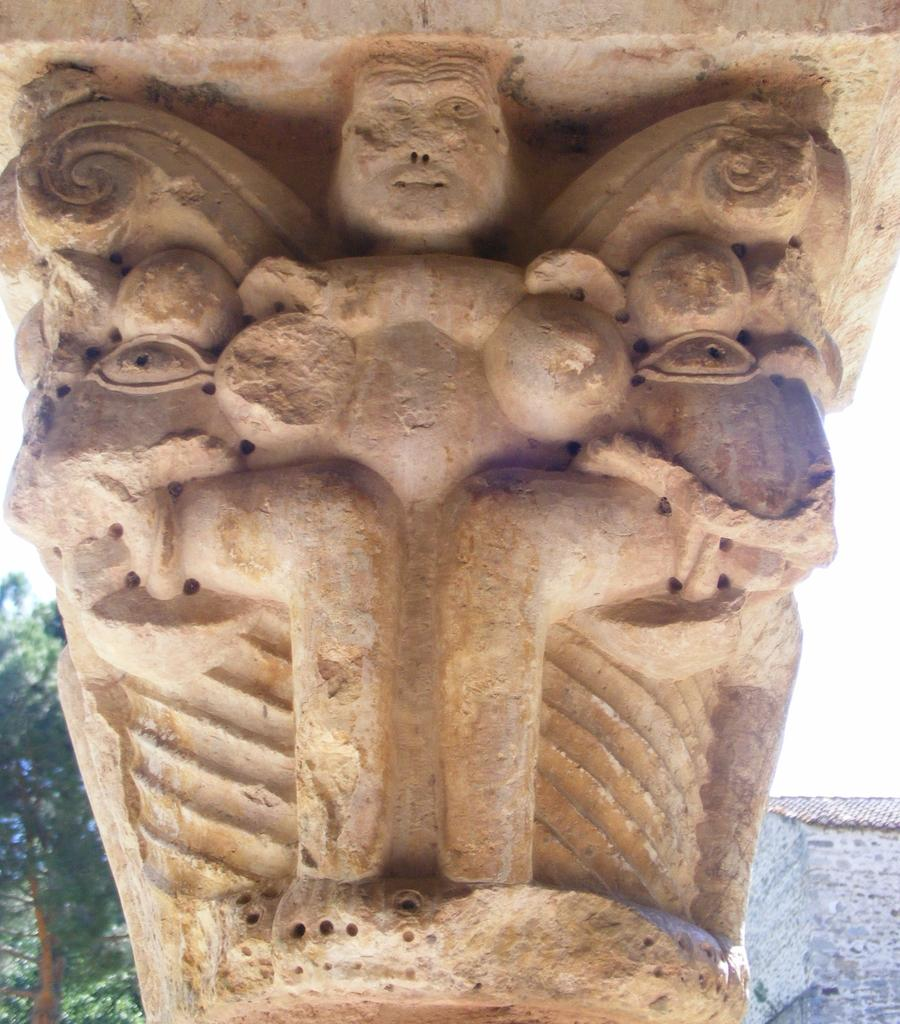What is the main subject of the image? There is a sculpture in the image. What can be seen in the background of the image? There are trees, a wall, and the sky visible in the background of the image. How many oranges are hanging from the branches of the trees in the image? There are no oranges visible in the image; only trees are present in the background. What type of soda is being poured into the sculpture in the image? There is no soda present in the image; it features a sculpture and trees in the background. 